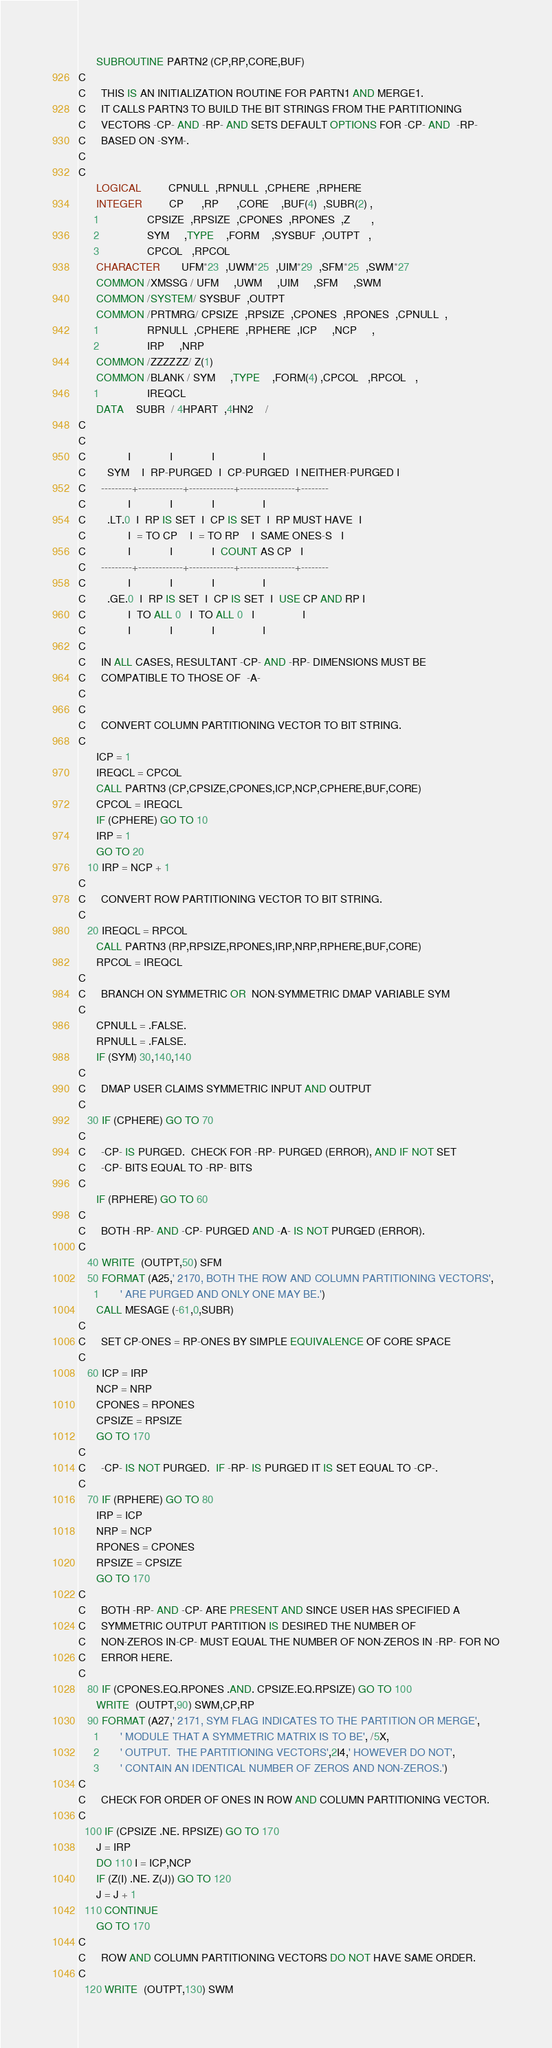Convert code to text. <code><loc_0><loc_0><loc_500><loc_500><_FORTRAN_>      SUBROUTINE PARTN2 (CP,RP,CORE,BUF)
C
C     THIS IS AN INITIALIZATION ROUTINE FOR PARTN1 AND MERGE1.
C     IT CALLS PARTN3 TO BUILD THE BIT STRINGS FROM THE PARTITIONING
C     VECTORS -CP- AND -RP- AND SETS DEFAULT OPTIONS FOR -CP- AND  -RP-
C     BASED ON -SYM-.
C
C
      LOGICAL         CPNULL  ,RPNULL  ,CPHERE  ,RPHERE
      INTEGER         CP      ,RP      ,CORE    ,BUF(4)  ,SUBR(2) ,
     1                CPSIZE  ,RPSIZE  ,CPONES  ,RPONES  ,Z       ,
     2                SYM     ,TYPE    ,FORM    ,SYSBUF  ,OUTPT   ,
     3                CPCOL   ,RPCOL
      CHARACTER       UFM*23  ,UWM*25  ,UIM*29  ,SFM*25  ,SWM*27
      COMMON /XMSSG / UFM     ,UWM     ,UIM     ,SFM     ,SWM
      COMMON /SYSTEM/ SYSBUF  ,OUTPT
      COMMON /PRTMRG/ CPSIZE  ,RPSIZE  ,CPONES  ,RPONES  ,CPNULL  ,
     1                RPNULL  ,CPHERE  ,RPHERE  ,ICP     ,NCP     ,
     2                IRP     ,NRP
      COMMON /ZZZZZZ/ Z(1)
      COMMON /BLANK / SYM     ,TYPE    ,FORM(4) ,CPCOL   ,RPCOL   ,
     1                IREQCL
      DATA    SUBR  / 4HPART  ,4HN2    /
C
C
C              I             I             I                I
C       SYM    I  RP-PURGED  I  CP-PURGED  I NEITHER-PURGED I
C     ---------+-------------+-------------+----------------+--------
C              I             I             I                I
C       .LT.0  I  RP IS SET  I  CP IS SET  I  RP MUST HAVE  I
C              I  = TO CP    I  = TO RP    I  SAME ONES-S   I
C              I             I             I  COUNT AS CP   I
C     ---------+-------------+-------------+----------------+--------
C              I             I             I                I
C       .GE.0  I  RP IS SET  I  CP IS SET  I  USE CP AND RP I
C              I  TO ALL 0   I  TO ALL 0   I                I
C              I             I             I                I
C
C     IN ALL CASES, RESULTANT -CP- AND -RP- DIMENSIONS MUST BE
C     COMPATIBLE TO THOSE OF  -A-
C
C
C     CONVERT COLUMN PARTITIONING VECTOR TO BIT STRING.
C
      ICP = 1
      IREQCL = CPCOL
      CALL PARTN3 (CP,CPSIZE,CPONES,ICP,NCP,CPHERE,BUF,CORE)
      CPCOL = IREQCL
      IF (CPHERE) GO TO 10
      IRP = 1
      GO TO 20
   10 IRP = NCP + 1
C
C     CONVERT ROW PARTITIONING VECTOR TO BIT STRING.
C
   20 IREQCL = RPCOL
      CALL PARTN3 (RP,RPSIZE,RPONES,IRP,NRP,RPHERE,BUF,CORE)
      RPCOL = IREQCL
C
C     BRANCH ON SYMMETRIC OR  NON-SYMMETRIC DMAP VARIABLE SYM
C
      CPNULL = .FALSE.
      RPNULL = .FALSE.
      IF (SYM) 30,140,140
C
C     DMAP USER CLAIMS SYMMETRIC INPUT AND OUTPUT
C
   30 IF (CPHERE) GO TO 70
C
C     -CP- IS PURGED.  CHECK FOR -RP- PURGED (ERROR), AND IF NOT SET
C     -CP- BITS EQUAL TO -RP- BITS
C
      IF (RPHERE) GO TO 60
C
C     BOTH -RP- AND -CP- PURGED AND -A- IS NOT PURGED (ERROR).
C
   40 WRITE  (OUTPT,50) SFM
   50 FORMAT (A25,' 2170, BOTH THE ROW AND COLUMN PARTITIONING VECTORS',
     1       ' ARE PURGED AND ONLY ONE MAY BE.')
      CALL MESAGE (-61,0,SUBR)
C
C     SET CP-ONES = RP-ONES BY SIMPLE EQUIVALENCE OF CORE SPACE
C
   60 ICP = IRP
      NCP = NRP
      CPONES = RPONES
      CPSIZE = RPSIZE
      GO TO 170
C
C     -CP- IS NOT PURGED.  IF -RP- IS PURGED IT IS SET EQUAL TO -CP-.
C
   70 IF (RPHERE) GO TO 80
      IRP = ICP
      NRP = NCP
      RPONES = CPONES
      RPSIZE = CPSIZE
      GO TO 170
C
C     BOTH -RP- AND -CP- ARE PRESENT AND SINCE USER HAS SPECIFIED A
C     SYMMETRIC OUTPUT PARTITION IS DESIRED THE NUMBER OF
C     NON-ZEROS IN-CP- MUST EQUAL THE NUMBER OF NON-ZEROS IN -RP- FOR NO
C     ERROR HERE.
C
   80 IF (CPONES.EQ.RPONES .AND. CPSIZE.EQ.RPSIZE) GO TO 100
      WRITE  (OUTPT,90) SWM,CP,RP
   90 FORMAT (A27,' 2171, SYM FLAG INDICATES TO THE PARTITION OR MERGE',
     1       ' MODULE THAT A SYMMETRIC MATRIX IS TO BE', /5X,
     2       ' OUTPUT.  THE PARTITIONING VECTORS',2I4,' HOWEVER DO NOT',
     3       ' CONTAIN AN IDENTICAL NUMBER OF ZEROS AND NON-ZEROS.')
C
C     CHECK FOR ORDER OF ONES IN ROW AND COLUMN PARTITIONING VECTOR.
C
  100 IF (CPSIZE .NE. RPSIZE) GO TO 170
      J = IRP
      DO 110 I = ICP,NCP
      IF (Z(I) .NE. Z(J)) GO TO 120
      J = J + 1
  110 CONTINUE
      GO TO 170
C
C     ROW AND COLUMN PARTITIONING VECTORS DO NOT HAVE SAME ORDER.
C
  120 WRITE  (OUTPT,130) SWM</code> 